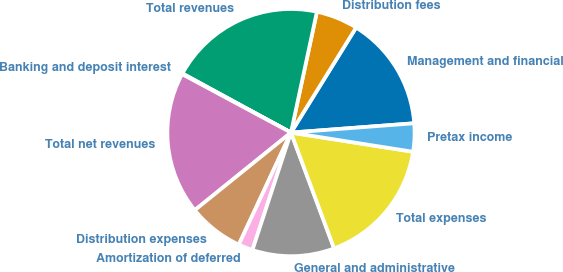Convert chart to OTSL. <chart><loc_0><loc_0><loc_500><loc_500><pie_chart><fcel>Management and financial<fcel>Distribution fees<fcel>Total revenues<fcel>Banking and deposit interest<fcel>Total net revenues<fcel>Distribution expenses<fcel>Amortization of deferred<fcel>General and administrative<fcel>Total expenses<fcel>Pretax income<nl><fcel>14.97%<fcel>5.47%<fcel>20.43%<fcel>0.1%<fcel>18.64%<fcel>7.26%<fcel>1.89%<fcel>10.72%<fcel>16.85%<fcel>3.68%<nl></chart> 